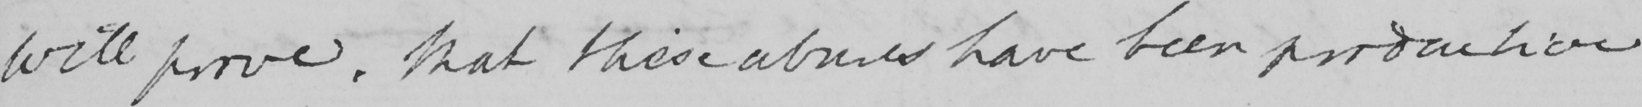Please provide the text content of this handwritten line. will prove that these abuses have been productive 